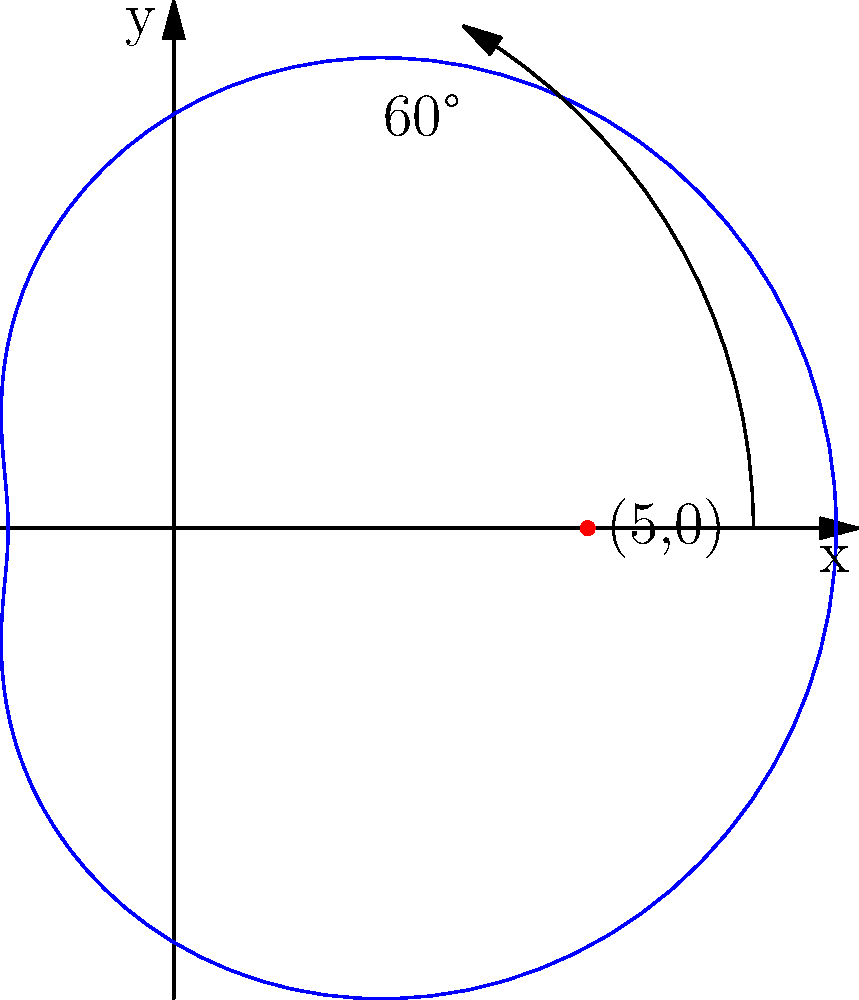A torpedo's trajectory in the waters near Pearl Harbor can be modeled using the polar equation $r = 5 + 3\cos(\theta)$, where $r$ is in nautical miles. If the torpedo is launched from the point (5,0) and travels along this path for 60°, what is its distance from the origin at this point? To solve this problem, we'll follow these steps:

1) The polar equation given is $r = 5 + 3\cos(\theta)$.

2) We need to find $r$ when $\theta = 60°$ or $\frac{\pi}{3}$ radians.

3) Substitute $\theta = \frac{\pi}{3}$ into the equation:

   $r = 5 + 3\cos(\frac{\pi}{3})$

4) Recall that $\cos(\frac{\pi}{3}) = \frac{1}{2}$

5) Now we can calculate:

   $r = 5 + 3(\frac{1}{2})$
   $r = 5 + \frac{3}{2}$
   $r = \frac{10}{2} + \frac{3}{2}$
   $r = \frac{13}{2}$
   $r = 6.5$

6) Therefore, after traveling 60°, the torpedo is 6.5 nautical miles from the origin.
Answer: 6.5 nautical miles 